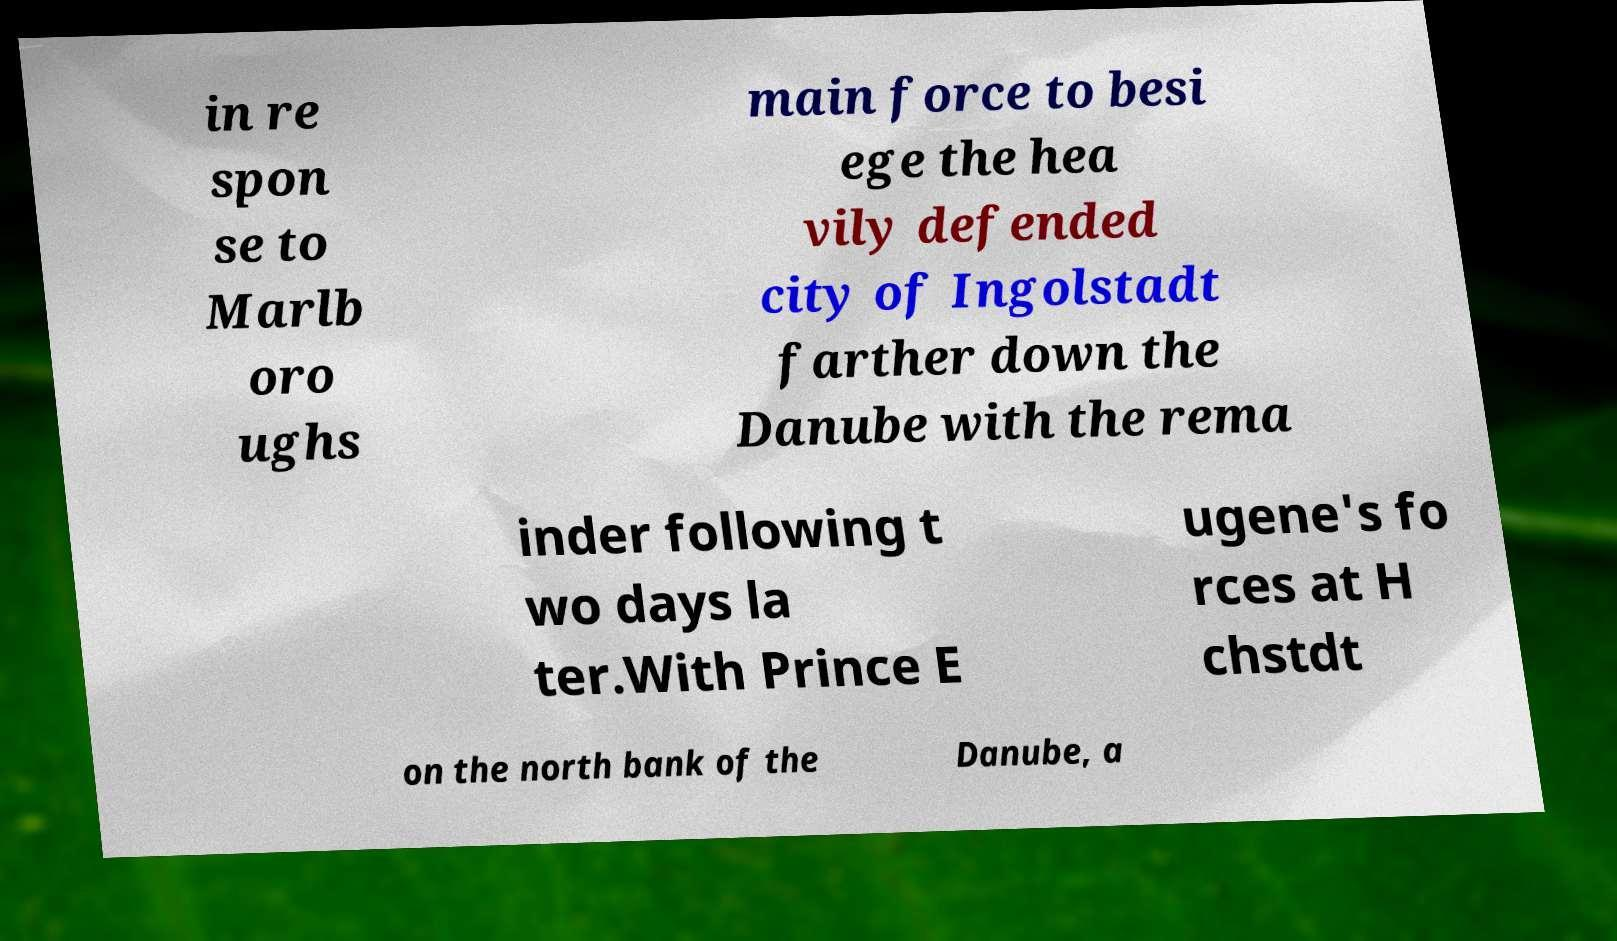Can you read and provide the text displayed in the image?This photo seems to have some interesting text. Can you extract and type it out for me? in re spon se to Marlb oro ughs main force to besi ege the hea vily defended city of Ingolstadt farther down the Danube with the rema inder following t wo days la ter.With Prince E ugene's fo rces at H chstdt on the north bank of the Danube, a 